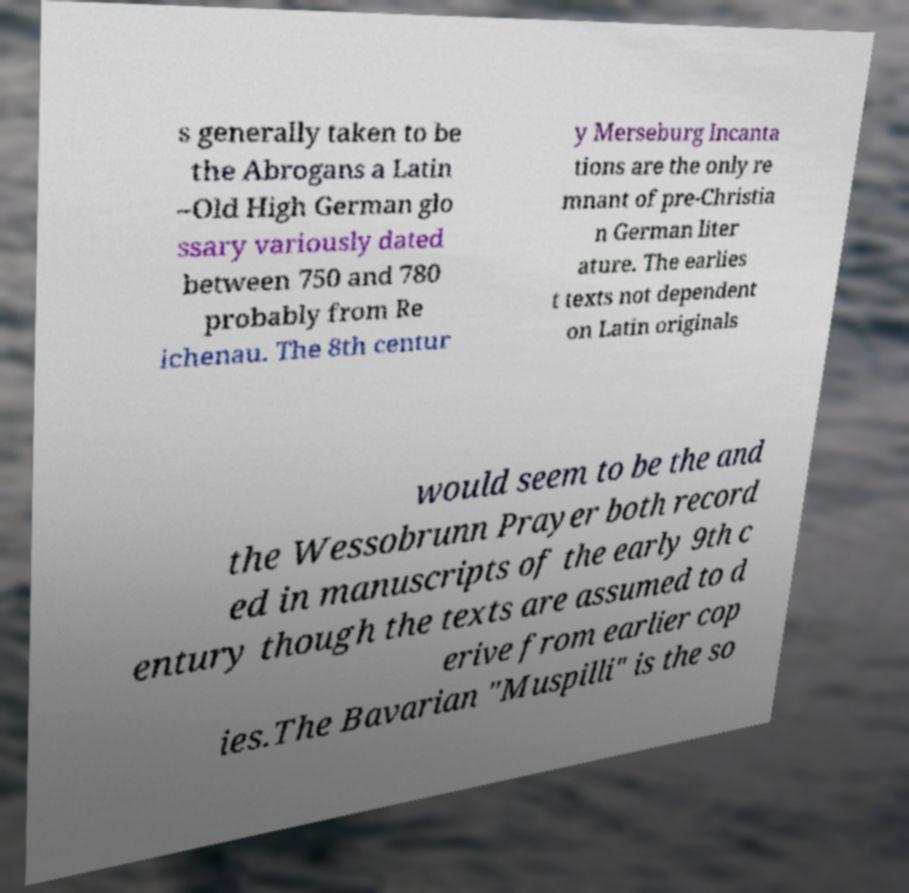Can you accurately transcribe the text from the provided image for me? s generally taken to be the Abrogans a Latin –Old High German glo ssary variously dated between 750 and 780 probably from Re ichenau. The 8th centur y Merseburg Incanta tions are the only re mnant of pre-Christia n German liter ature. The earlies t texts not dependent on Latin originals would seem to be the and the Wessobrunn Prayer both record ed in manuscripts of the early 9th c entury though the texts are assumed to d erive from earlier cop ies.The Bavarian "Muspilli" is the so 